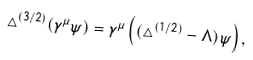Convert formula to latex. <formula><loc_0><loc_0><loc_500><loc_500>\triangle ^ { ( 3 / 2 ) } ( \gamma ^ { \mu } \psi ) = \gamma ^ { \mu } \left ( ( \triangle ^ { ( 1 / 2 ) } - \Lambda ) \psi \right ) ,</formula> 